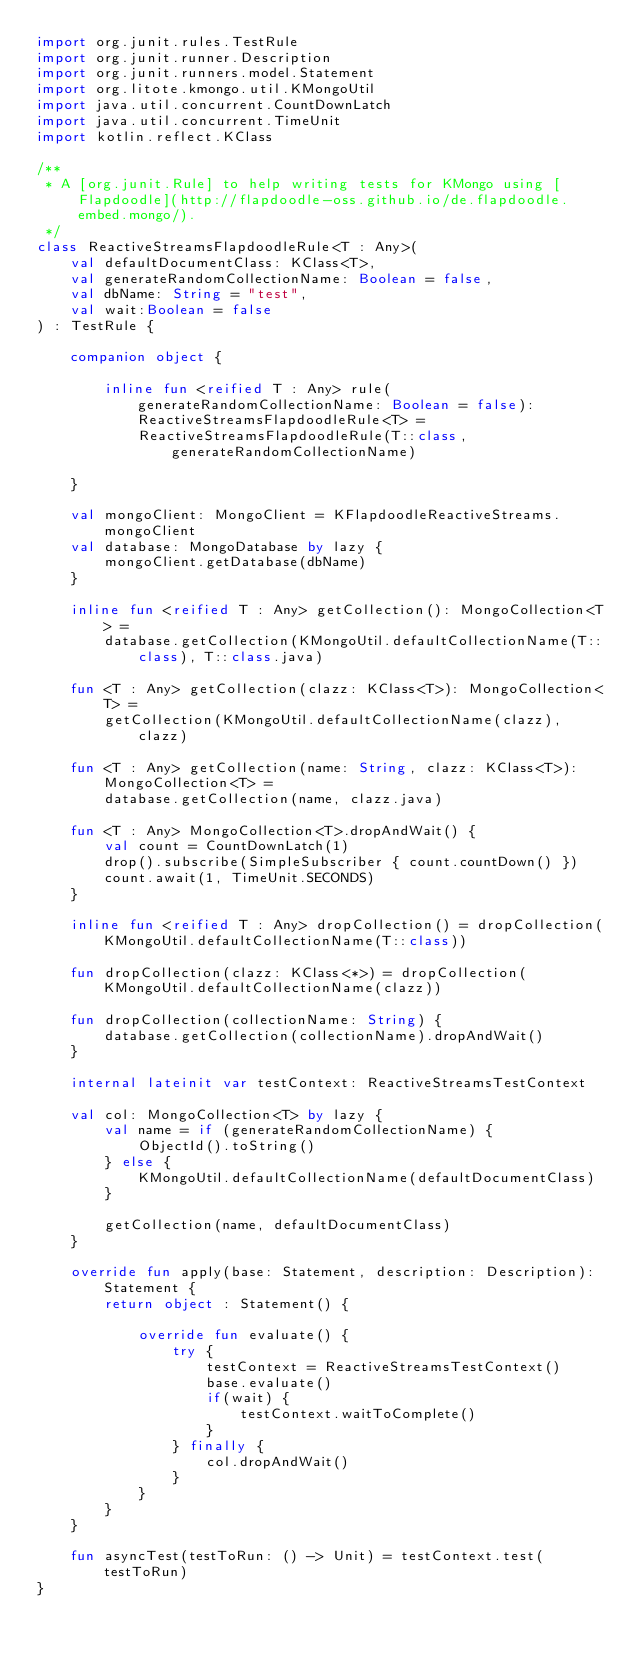Convert code to text. <code><loc_0><loc_0><loc_500><loc_500><_Kotlin_>import org.junit.rules.TestRule
import org.junit.runner.Description
import org.junit.runners.model.Statement
import org.litote.kmongo.util.KMongoUtil
import java.util.concurrent.CountDownLatch
import java.util.concurrent.TimeUnit
import kotlin.reflect.KClass

/**
 * A [org.junit.Rule] to help writing tests for KMongo using [Flapdoodle](http://flapdoodle-oss.github.io/de.flapdoodle.embed.mongo/).
 */
class ReactiveStreamsFlapdoodleRule<T : Any>(
    val defaultDocumentClass: KClass<T>,
    val generateRandomCollectionName: Boolean = false,
    val dbName: String = "test",
    val wait:Boolean = false
) : TestRule {

    companion object {

        inline fun <reified T : Any> rule(generateRandomCollectionName: Boolean = false): ReactiveStreamsFlapdoodleRule<T> =
            ReactiveStreamsFlapdoodleRule(T::class, generateRandomCollectionName)

    }

    val mongoClient: MongoClient = KFlapdoodleReactiveStreams.mongoClient
    val database: MongoDatabase by lazy {
        mongoClient.getDatabase(dbName)
    }

    inline fun <reified T : Any> getCollection(): MongoCollection<T> =
        database.getCollection(KMongoUtil.defaultCollectionName(T::class), T::class.java)

    fun <T : Any> getCollection(clazz: KClass<T>): MongoCollection<T> =
        getCollection(KMongoUtil.defaultCollectionName(clazz), clazz)

    fun <T : Any> getCollection(name: String, clazz: KClass<T>): MongoCollection<T> =
        database.getCollection(name, clazz.java)

    fun <T : Any> MongoCollection<T>.dropAndWait() {
        val count = CountDownLatch(1)
        drop().subscribe(SimpleSubscriber { count.countDown() })
        count.await(1, TimeUnit.SECONDS)
    }

    inline fun <reified T : Any> dropCollection() = dropCollection(KMongoUtil.defaultCollectionName(T::class))

    fun dropCollection(clazz: KClass<*>) = dropCollection(KMongoUtil.defaultCollectionName(clazz))

    fun dropCollection(collectionName: String) {
        database.getCollection(collectionName).dropAndWait()
    }

    internal lateinit var testContext: ReactiveStreamsTestContext

    val col: MongoCollection<T> by lazy {
        val name = if (generateRandomCollectionName) {
            ObjectId().toString()
        } else {
            KMongoUtil.defaultCollectionName(defaultDocumentClass)
        }

        getCollection(name, defaultDocumentClass)
    }

    override fun apply(base: Statement, description: Description): Statement {
        return object : Statement() {

            override fun evaluate() {
                try {
                    testContext = ReactiveStreamsTestContext()
                    base.evaluate()
                    if(wait) {
                        testContext.waitToComplete()
                    }
                } finally {
                    col.dropAndWait()
                }
            }
        }
    }

    fun asyncTest(testToRun: () -> Unit) = testContext.test(testToRun)
}</code> 